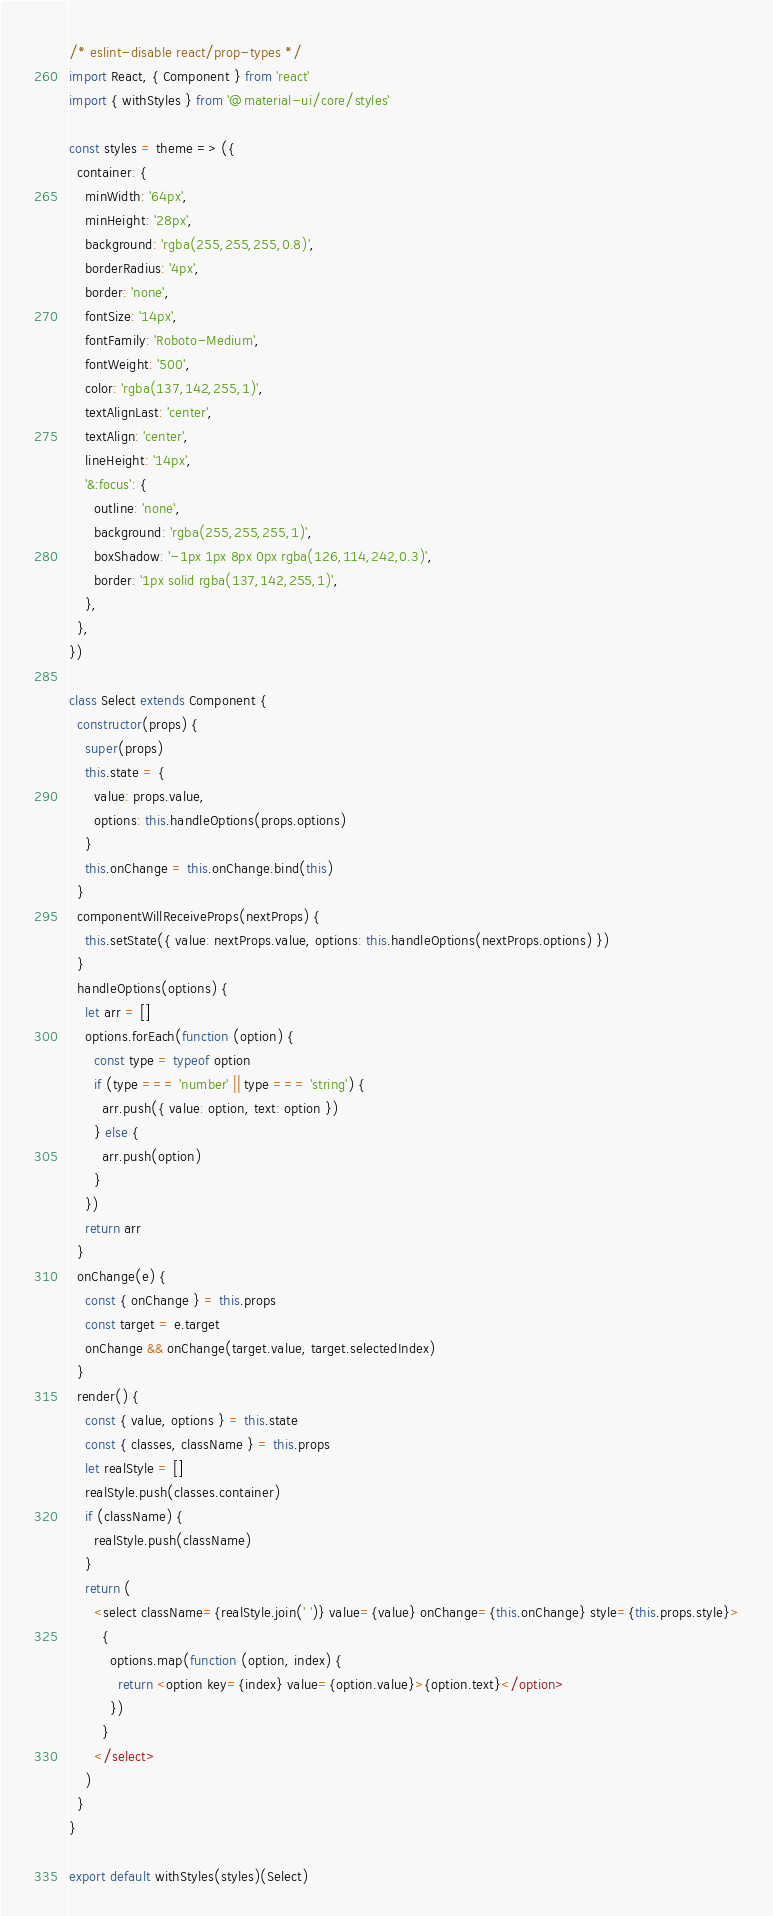Convert code to text. <code><loc_0><loc_0><loc_500><loc_500><_JavaScript_>/* eslint-disable react/prop-types */
import React, { Component } from 'react'
import { withStyles } from '@material-ui/core/styles'

const styles = theme => ({
  container: {
    minWidth: '64px',
    minHeight: '28px',
    background: 'rgba(255,255,255,0.8)',
    borderRadius: '4px',
    border: 'none',
    fontSize: '14px',
    fontFamily: 'Roboto-Medium',
    fontWeight: '500',
    color: 'rgba(137,142,255,1)',
    textAlignLast: 'center',
    textAlign: 'center',
    lineHeight: '14px',
    '&:focus': {
      outline: 'none',
      background: 'rgba(255,255,255,1)',
      boxShadow: '-1px 1px 8px 0px rgba(126,114,242,0.3)',
      border: '1px solid rgba(137,142,255,1)',
    },
  },
})

class Select extends Component {
  constructor(props) {
    super(props)
    this.state = {
      value: props.value,
      options: this.handleOptions(props.options)
    }
    this.onChange = this.onChange.bind(this)
  }
  componentWillReceiveProps(nextProps) {
    this.setState({ value: nextProps.value, options: this.handleOptions(nextProps.options) })
  }
  handleOptions(options) {
    let arr = []
    options.forEach(function (option) {
      const type = typeof option
      if (type === 'number' || type === 'string') {
        arr.push({ value: option, text: option })
      } else {
        arr.push(option)
      }
    })
    return arr
  }
  onChange(e) {
    const { onChange } = this.props
    const target = e.target
    onChange && onChange(target.value, target.selectedIndex)
  }
  render() {
    const { value, options } = this.state
    const { classes, className } = this.props
    let realStyle = []
    realStyle.push(classes.container)
    if (className) {
      realStyle.push(className)
    }
    return (
      <select className={realStyle.join(' ')} value={value} onChange={this.onChange} style={this.props.style}>
        {
          options.map(function (option, index) {
            return <option key={index} value={option.value}>{option.text}</option>
          })
        }
      </select>
    )
  }
}

export default withStyles(styles)(Select)
</code> 